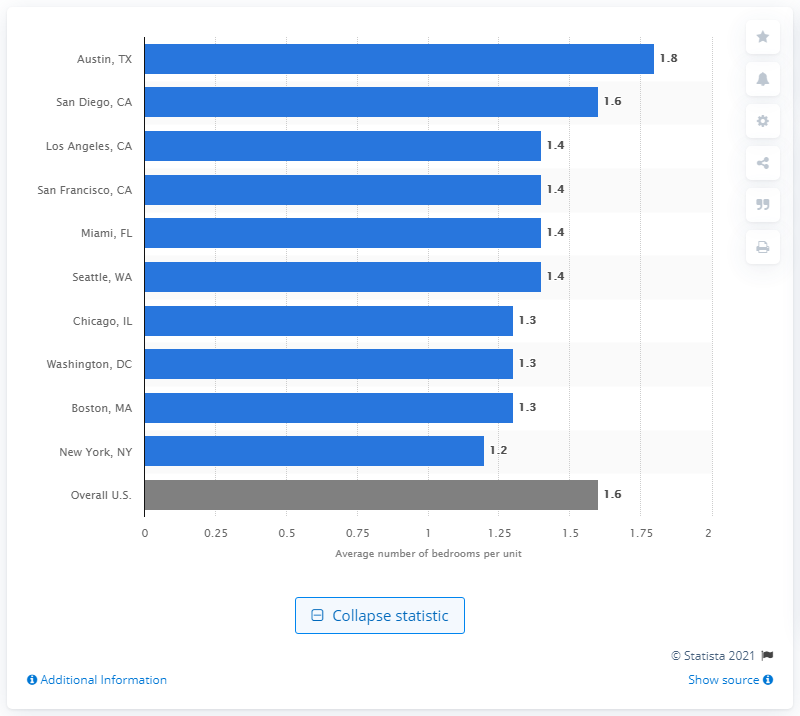Draw attention to some important aspects in this diagram. In 2015, the average number of bedrooms per unit in Austin was 1.8. 